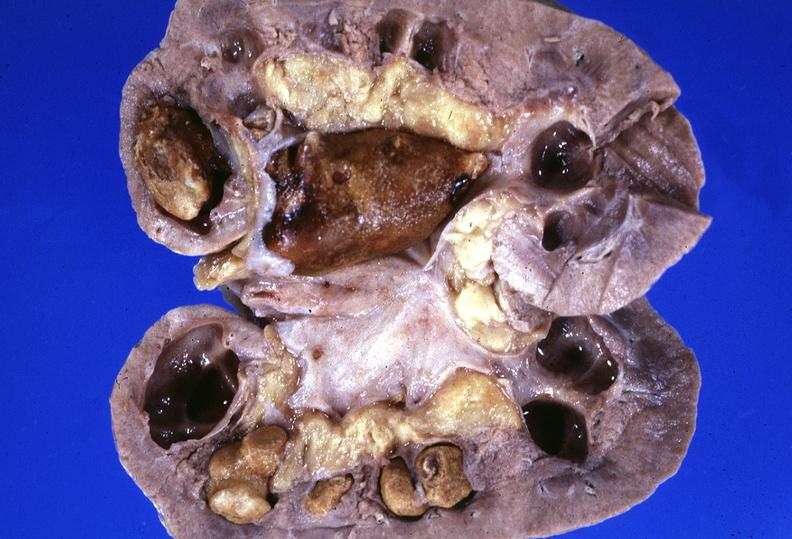where is this?
Answer the question using a single word or phrase. Urinary 